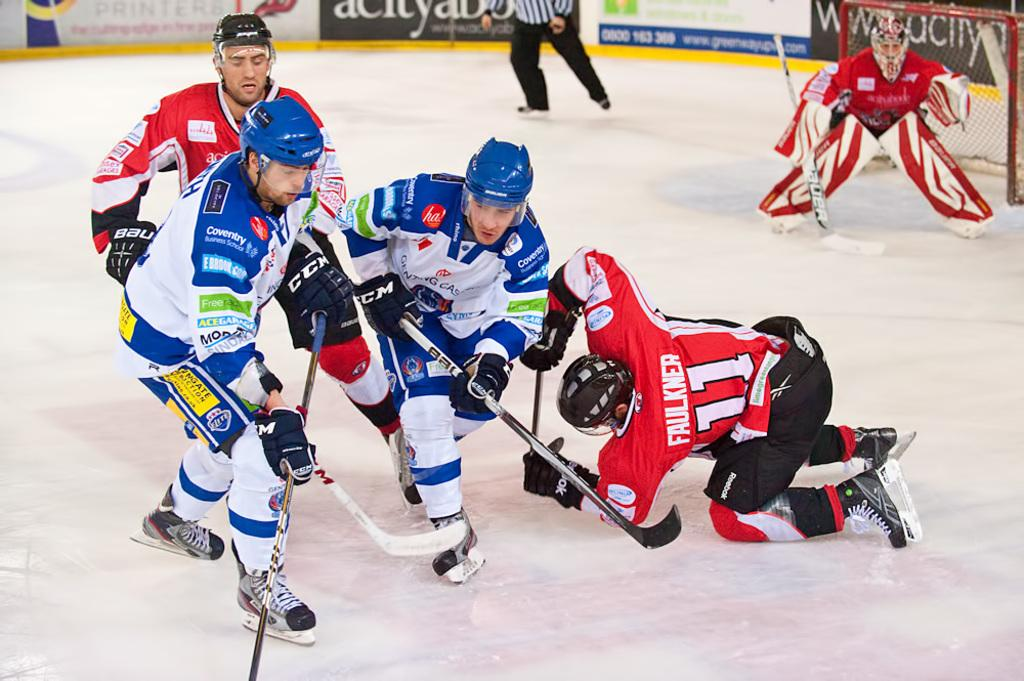<image>
Render a clear and concise summary of the photo. A hockey player with a red shirt named Faulkner with the number 11. 